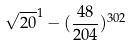<formula> <loc_0><loc_0><loc_500><loc_500>\sqrt { 2 0 } ^ { 1 } - ( \frac { 4 8 } { 2 0 4 } ) ^ { 3 0 2 }</formula> 